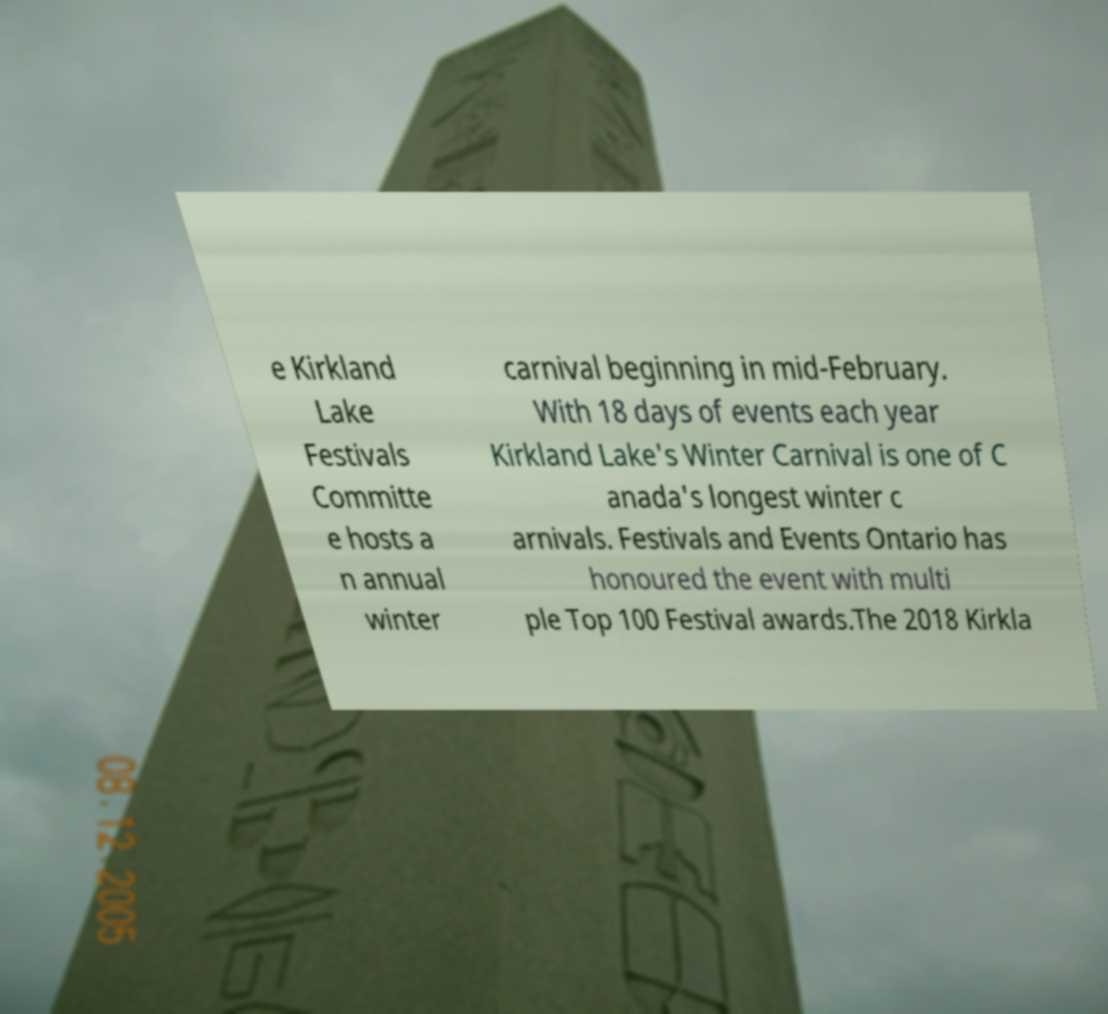Please read and relay the text visible in this image. What does it say? e Kirkland Lake Festivals Committe e hosts a n annual winter carnival beginning in mid-February. With 18 days of events each year Kirkland Lake's Winter Carnival is one of C anada's longest winter c arnivals. Festivals and Events Ontario has honoured the event with multi ple Top 100 Festival awards.The 2018 Kirkla 